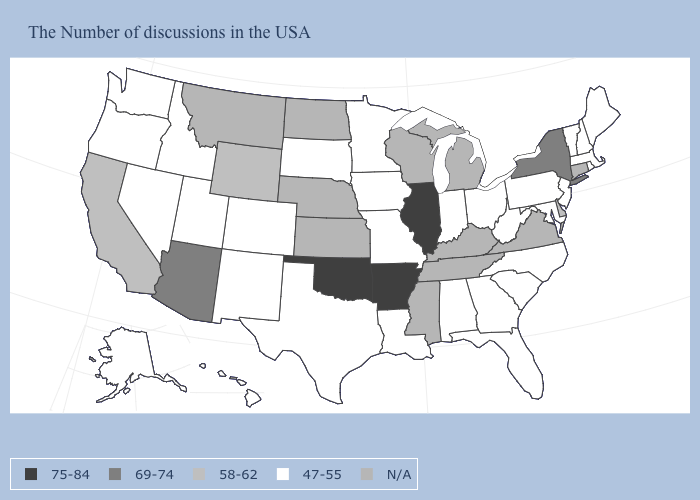Name the states that have a value in the range 47-55?
Answer briefly. Maine, Massachusetts, Rhode Island, New Hampshire, Vermont, New Jersey, Maryland, Pennsylvania, North Carolina, South Carolina, West Virginia, Ohio, Florida, Georgia, Indiana, Alabama, Louisiana, Missouri, Minnesota, Iowa, Texas, South Dakota, Colorado, New Mexico, Utah, Idaho, Nevada, Washington, Oregon, Alaska, Hawaii. Does Washington have the lowest value in the West?
Answer briefly. Yes. What is the value of Ohio?
Quick response, please. 47-55. What is the lowest value in the MidWest?
Be succinct. 47-55. What is the value of Colorado?
Quick response, please. 47-55. Name the states that have a value in the range N/A?
Write a very short answer. Connecticut, Virginia, Michigan, Kentucky, Tennessee, Wisconsin, Mississippi, Kansas, Nebraska, North Dakota, Montana. Which states have the lowest value in the MidWest?
Concise answer only. Ohio, Indiana, Missouri, Minnesota, Iowa, South Dakota. Does the map have missing data?
Concise answer only. Yes. What is the value of Oregon?
Short answer required. 47-55. Name the states that have a value in the range N/A?
Short answer required. Connecticut, Virginia, Michigan, Kentucky, Tennessee, Wisconsin, Mississippi, Kansas, Nebraska, North Dakota, Montana. Name the states that have a value in the range 47-55?
Give a very brief answer. Maine, Massachusetts, Rhode Island, New Hampshire, Vermont, New Jersey, Maryland, Pennsylvania, North Carolina, South Carolina, West Virginia, Ohio, Florida, Georgia, Indiana, Alabama, Louisiana, Missouri, Minnesota, Iowa, Texas, South Dakota, Colorado, New Mexico, Utah, Idaho, Nevada, Washington, Oregon, Alaska, Hawaii. What is the lowest value in the Northeast?
Write a very short answer. 47-55. 